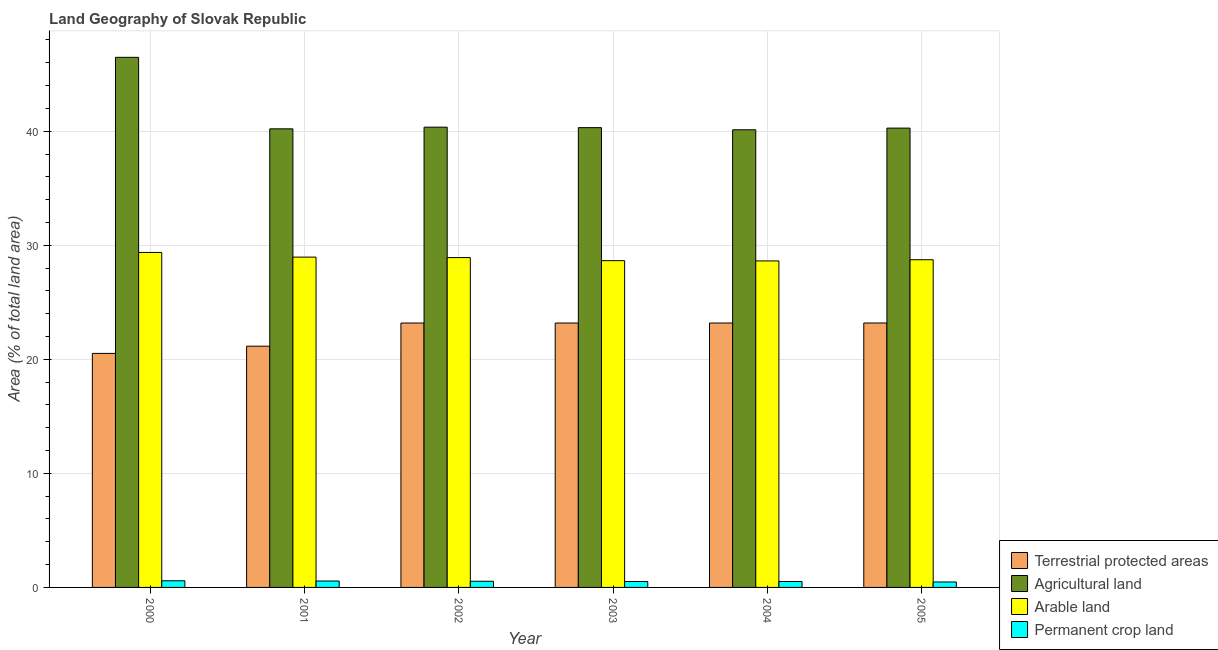How many different coloured bars are there?
Provide a succinct answer. 4. Are the number of bars per tick equal to the number of legend labels?
Make the answer very short. Yes. In how many cases, is the number of bars for a given year not equal to the number of legend labels?
Ensure brevity in your answer.  0. What is the percentage of area under permanent crop land in 2004?
Your answer should be compact. 0.52. Across all years, what is the maximum percentage of area under arable land?
Offer a terse response. 29.37. Across all years, what is the minimum percentage of area under agricultural land?
Your response must be concise. 40.12. In which year was the percentage of area under permanent crop land minimum?
Ensure brevity in your answer.  2005. What is the total percentage of area under permanent crop land in the graph?
Keep it short and to the point. 3.2. What is the difference between the percentage of area under permanent crop land in 2001 and that in 2003?
Give a very brief answer. 0.04. What is the difference between the percentage of area under arable land in 2003 and the percentage of land under terrestrial protection in 2002?
Offer a very short reply. -0.27. What is the average percentage of area under permanent crop land per year?
Provide a short and direct response. 0.53. What is the ratio of the percentage of area under agricultural land in 2000 to that in 2004?
Make the answer very short. 1.16. What is the difference between the highest and the second highest percentage of area under agricultural land?
Ensure brevity in your answer.  6.12. What is the difference between the highest and the lowest percentage of area under permanent crop land?
Your response must be concise. 0.1. Is the sum of the percentage of land under terrestrial protection in 2000 and 2005 greater than the maximum percentage of area under permanent crop land across all years?
Ensure brevity in your answer.  Yes. What does the 4th bar from the left in 2000 represents?
Your response must be concise. Permanent crop land. What does the 1st bar from the right in 2001 represents?
Keep it short and to the point. Permanent crop land. Is it the case that in every year, the sum of the percentage of land under terrestrial protection and percentage of area under agricultural land is greater than the percentage of area under arable land?
Keep it short and to the point. Yes. How many bars are there?
Offer a terse response. 24. Are the values on the major ticks of Y-axis written in scientific E-notation?
Make the answer very short. No. Does the graph contain any zero values?
Offer a very short reply. No. Where does the legend appear in the graph?
Provide a short and direct response. Bottom right. How many legend labels are there?
Provide a short and direct response. 4. What is the title of the graph?
Ensure brevity in your answer.  Land Geography of Slovak Republic. What is the label or title of the Y-axis?
Provide a short and direct response. Area (% of total land area). What is the Area (% of total land area) of Terrestrial protected areas in 2000?
Give a very brief answer. 20.52. What is the Area (% of total land area) of Agricultural land in 2000?
Give a very brief answer. 46.48. What is the Area (% of total land area) in Arable land in 2000?
Keep it short and to the point. 29.37. What is the Area (% of total land area) of Permanent crop land in 2000?
Provide a short and direct response. 0.58. What is the Area (% of total land area) of Terrestrial protected areas in 2001?
Your response must be concise. 21.15. What is the Area (% of total land area) of Agricultural land in 2001?
Your answer should be compact. 40.21. What is the Area (% of total land area) in Arable land in 2001?
Offer a very short reply. 28.96. What is the Area (% of total land area) in Permanent crop land in 2001?
Keep it short and to the point. 0.56. What is the Area (% of total land area) of Terrestrial protected areas in 2002?
Provide a short and direct response. 23.18. What is the Area (% of total land area) of Agricultural land in 2002?
Keep it short and to the point. 40.35. What is the Area (% of total land area) in Arable land in 2002?
Provide a short and direct response. 28.92. What is the Area (% of total land area) of Permanent crop land in 2002?
Your response must be concise. 0.54. What is the Area (% of total land area) of Terrestrial protected areas in 2003?
Provide a short and direct response. 23.18. What is the Area (% of total land area) of Agricultural land in 2003?
Give a very brief answer. 40.31. What is the Area (% of total land area) in Arable land in 2003?
Ensure brevity in your answer.  28.65. What is the Area (% of total land area) in Permanent crop land in 2003?
Make the answer very short. 0.52. What is the Area (% of total land area) in Terrestrial protected areas in 2004?
Offer a very short reply. 23.18. What is the Area (% of total land area) in Agricultural land in 2004?
Your response must be concise. 40.12. What is the Area (% of total land area) in Arable land in 2004?
Your answer should be very brief. 28.63. What is the Area (% of total land area) in Permanent crop land in 2004?
Make the answer very short. 0.52. What is the Area (% of total land area) of Terrestrial protected areas in 2005?
Offer a very short reply. 23.18. What is the Area (% of total land area) of Agricultural land in 2005?
Your answer should be very brief. 40.27. What is the Area (% of total land area) in Arable land in 2005?
Your answer should be very brief. 28.73. What is the Area (% of total land area) in Permanent crop land in 2005?
Ensure brevity in your answer.  0.48. Across all years, what is the maximum Area (% of total land area) in Terrestrial protected areas?
Offer a very short reply. 23.18. Across all years, what is the maximum Area (% of total land area) of Agricultural land?
Your answer should be compact. 46.48. Across all years, what is the maximum Area (% of total land area) of Arable land?
Make the answer very short. 29.37. Across all years, what is the maximum Area (% of total land area) of Permanent crop land?
Offer a terse response. 0.58. Across all years, what is the minimum Area (% of total land area) in Terrestrial protected areas?
Keep it short and to the point. 20.52. Across all years, what is the minimum Area (% of total land area) in Agricultural land?
Provide a short and direct response. 40.12. Across all years, what is the minimum Area (% of total land area) in Arable land?
Offer a very short reply. 28.63. Across all years, what is the minimum Area (% of total land area) of Permanent crop land?
Offer a very short reply. 0.48. What is the total Area (% of total land area) in Terrestrial protected areas in the graph?
Ensure brevity in your answer.  134.4. What is the total Area (% of total land area) of Agricultural land in the graph?
Provide a succinct answer. 247.75. What is the total Area (% of total land area) in Arable land in the graph?
Your answer should be very brief. 173.26. What is the total Area (% of total land area) of Permanent crop land in the graph?
Give a very brief answer. 3.2. What is the difference between the Area (% of total land area) in Terrestrial protected areas in 2000 and that in 2001?
Your answer should be very brief. -0.63. What is the difference between the Area (% of total land area) of Agricultural land in 2000 and that in 2001?
Give a very brief answer. 6.27. What is the difference between the Area (% of total land area) of Arable land in 2000 and that in 2001?
Provide a succinct answer. 0.41. What is the difference between the Area (% of total land area) of Permanent crop land in 2000 and that in 2001?
Make the answer very short. 0.02. What is the difference between the Area (% of total land area) of Terrestrial protected areas in 2000 and that in 2002?
Offer a very short reply. -2.66. What is the difference between the Area (% of total land area) of Agricultural land in 2000 and that in 2002?
Keep it short and to the point. 6.12. What is the difference between the Area (% of total land area) in Arable land in 2000 and that in 2002?
Your answer should be very brief. 0.45. What is the difference between the Area (% of total land area) of Permanent crop land in 2000 and that in 2002?
Your response must be concise. 0.04. What is the difference between the Area (% of total land area) of Terrestrial protected areas in 2000 and that in 2003?
Offer a terse response. -2.66. What is the difference between the Area (% of total land area) in Agricultural land in 2000 and that in 2003?
Give a very brief answer. 6.17. What is the difference between the Area (% of total land area) in Arable land in 2000 and that in 2003?
Your response must be concise. 0.72. What is the difference between the Area (% of total land area) of Permanent crop land in 2000 and that in 2003?
Your answer should be very brief. 0.06. What is the difference between the Area (% of total land area) of Terrestrial protected areas in 2000 and that in 2004?
Your answer should be compact. -2.66. What is the difference between the Area (% of total land area) in Agricultural land in 2000 and that in 2004?
Give a very brief answer. 6.35. What is the difference between the Area (% of total land area) of Arable land in 2000 and that in 2004?
Make the answer very short. 0.74. What is the difference between the Area (% of total land area) in Permanent crop land in 2000 and that in 2004?
Offer a terse response. 0.06. What is the difference between the Area (% of total land area) of Terrestrial protected areas in 2000 and that in 2005?
Provide a short and direct response. -2.67. What is the difference between the Area (% of total land area) in Agricultural land in 2000 and that in 2005?
Offer a very short reply. 6.21. What is the difference between the Area (% of total land area) in Arable land in 2000 and that in 2005?
Keep it short and to the point. 0.64. What is the difference between the Area (% of total land area) of Permanent crop land in 2000 and that in 2005?
Your response must be concise. 0.1. What is the difference between the Area (% of total land area) of Terrestrial protected areas in 2001 and that in 2002?
Your answer should be compact. -2.03. What is the difference between the Area (% of total land area) of Agricultural land in 2001 and that in 2002?
Your answer should be compact. -0.15. What is the difference between the Area (% of total land area) of Arable land in 2001 and that in 2002?
Ensure brevity in your answer.  0.04. What is the difference between the Area (% of total land area) of Permanent crop land in 2001 and that in 2002?
Provide a short and direct response. 0.02. What is the difference between the Area (% of total land area) in Terrestrial protected areas in 2001 and that in 2003?
Your answer should be compact. -2.03. What is the difference between the Area (% of total land area) in Agricultural land in 2001 and that in 2003?
Keep it short and to the point. -0.1. What is the difference between the Area (% of total land area) of Arable land in 2001 and that in 2003?
Give a very brief answer. 0.31. What is the difference between the Area (% of total land area) in Permanent crop land in 2001 and that in 2003?
Offer a very short reply. 0.04. What is the difference between the Area (% of total land area) in Terrestrial protected areas in 2001 and that in 2004?
Your answer should be compact. -2.03. What is the difference between the Area (% of total land area) of Agricultural land in 2001 and that in 2004?
Your answer should be compact. 0.08. What is the difference between the Area (% of total land area) in Arable land in 2001 and that in 2004?
Give a very brief answer. 0.33. What is the difference between the Area (% of total land area) of Permanent crop land in 2001 and that in 2004?
Provide a succinct answer. 0.04. What is the difference between the Area (% of total land area) in Terrestrial protected areas in 2001 and that in 2005?
Provide a succinct answer. -2.03. What is the difference between the Area (% of total land area) of Agricultural land in 2001 and that in 2005?
Your answer should be compact. -0.06. What is the difference between the Area (% of total land area) of Arable land in 2001 and that in 2005?
Provide a succinct answer. 0.23. What is the difference between the Area (% of total land area) in Permanent crop land in 2001 and that in 2005?
Offer a very short reply. 0.08. What is the difference between the Area (% of total land area) in Terrestrial protected areas in 2002 and that in 2003?
Offer a very short reply. -0. What is the difference between the Area (% of total land area) in Agricultural land in 2002 and that in 2003?
Ensure brevity in your answer.  0.04. What is the difference between the Area (% of total land area) of Arable land in 2002 and that in 2003?
Make the answer very short. 0.27. What is the difference between the Area (% of total land area) of Permanent crop land in 2002 and that in 2003?
Keep it short and to the point. 0.02. What is the difference between the Area (% of total land area) in Terrestrial protected areas in 2002 and that in 2004?
Make the answer very short. -0. What is the difference between the Area (% of total land area) in Agricultural land in 2002 and that in 2004?
Give a very brief answer. 0.23. What is the difference between the Area (% of total land area) of Arable land in 2002 and that in 2004?
Your answer should be very brief. 0.29. What is the difference between the Area (% of total land area) in Permanent crop land in 2002 and that in 2004?
Give a very brief answer. 0.02. What is the difference between the Area (% of total land area) of Terrestrial protected areas in 2002 and that in 2005?
Provide a succinct answer. -0. What is the difference between the Area (% of total land area) in Agricultural land in 2002 and that in 2005?
Offer a very short reply. 0.08. What is the difference between the Area (% of total land area) in Arable land in 2002 and that in 2005?
Your response must be concise. 0.19. What is the difference between the Area (% of total land area) in Permanent crop land in 2002 and that in 2005?
Ensure brevity in your answer.  0.06. What is the difference between the Area (% of total land area) of Terrestrial protected areas in 2003 and that in 2004?
Your answer should be compact. -0. What is the difference between the Area (% of total land area) in Agricultural land in 2003 and that in 2004?
Make the answer very short. 0.19. What is the difference between the Area (% of total land area) of Arable land in 2003 and that in 2004?
Give a very brief answer. 0.02. What is the difference between the Area (% of total land area) of Permanent crop land in 2003 and that in 2004?
Give a very brief answer. 0. What is the difference between the Area (% of total land area) of Terrestrial protected areas in 2003 and that in 2005?
Ensure brevity in your answer.  -0. What is the difference between the Area (% of total land area) in Agricultural land in 2003 and that in 2005?
Make the answer very short. 0.04. What is the difference between the Area (% of total land area) of Arable land in 2003 and that in 2005?
Make the answer very short. -0.08. What is the difference between the Area (% of total land area) in Permanent crop land in 2003 and that in 2005?
Ensure brevity in your answer.  0.04. What is the difference between the Area (% of total land area) in Terrestrial protected areas in 2004 and that in 2005?
Keep it short and to the point. -0. What is the difference between the Area (% of total land area) in Agricultural land in 2004 and that in 2005?
Ensure brevity in your answer.  -0.15. What is the difference between the Area (% of total land area) of Arable land in 2004 and that in 2005?
Your response must be concise. -0.1. What is the difference between the Area (% of total land area) of Permanent crop land in 2004 and that in 2005?
Your answer should be compact. 0.04. What is the difference between the Area (% of total land area) of Terrestrial protected areas in 2000 and the Area (% of total land area) of Agricultural land in 2001?
Offer a terse response. -19.69. What is the difference between the Area (% of total land area) of Terrestrial protected areas in 2000 and the Area (% of total land area) of Arable land in 2001?
Give a very brief answer. -8.44. What is the difference between the Area (% of total land area) of Terrestrial protected areas in 2000 and the Area (% of total land area) of Permanent crop land in 2001?
Ensure brevity in your answer.  19.96. What is the difference between the Area (% of total land area) of Agricultural land in 2000 and the Area (% of total land area) of Arable land in 2001?
Keep it short and to the point. 17.52. What is the difference between the Area (% of total land area) of Agricultural land in 2000 and the Area (% of total land area) of Permanent crop land in 2001?
Give a very brief answer. 45.92. What is the difference between the Area (% of total land area) of Arable land in 2000 and the Area (% of total land area) of Permanent crop land in 2001?
Offer a terse response. 28.81. What is the difference between the Area (% of total land area) in Terrestrial protected areas in 2000 and the Area (% of total land area) in Agricultural land in 2002?
Ensure brevity in your answer.  -19.83. What is the difference between the Area (% of total land area) in Terrestrial protected areas in 2000 and the Area (% of total land area) in Arable land in 2002?
Keep it short and to the point. -8.4. What is the difference between the Area (% of total land area) in Terrestrial protected areas in 2000 and the Area (% of total land area) in Permanent crop land in 2002?
Your answer should be compact. 19.98. What is the difference between the Area (% of total land area) of Agricultural land in 2000 and the Area (% of total land area) of Arable land in 2002?
Your answer should be very brief. 17.56. What is the difference between the Area (% of total land area) of Agricultural land in 2000 and the Area (% of total land area) of Permanent crop land in 2002?
Provide a short and direct response. 45.94. What is the difference between the Area (% of total land area) of Arable land in 2000 and the Area (% of total land area) of Permanent crop land in 2002?
Provide a succinct answer. 28.83. What is the difference between the Area (% of total land area) in Terrestrial protected areas in 2000 and the Area (% of total land area) in Agricultural land in 2003?
Your answer should be compact. -19.79. What is the difference between the Area (% of total land area) in Terrestrial protected areas in 2000 and the Area (% of total land area) in Arable land in 2003?
Your answer should be very brief. -8.13. What is the difference between the Area (% of total land area) in Terrestrial protected areas in 2000 and the Area (% of total land area) in Permanent crop land in 2003?
Offer a terse response. 20. What is the difference between the Area (% of total land area) of Agricultural land in 2000 and the Area (% of total land area) of Arable land in 2003?
Your answer should be compact. 17.83. What is the difference between the Area (% of total land area) in Agricultural land in 2000 and the Area (% of total land area) in Permanent crop land in 2003?
Provide a short and direct response. 45.96. What is the difference between the Area (% of total land area) of Arable land in 2000 and the Area (% of total land area) of Permanent crop land in 2003?
Offer a terse response. 28.85. What is the difference between the Area (% of total land area) of Terrestrial protected areas in 2000 and the Area (% of total land area) of Agricultural land in 2004?
Give a very brief answer. -19.61. What is the difference between the Area (% of total land area) in Terrestrial protected areas in 2000 and the Area (% of total land area) in Arable land in 2004?
Give a very brief answer. -8.11. What is the difference between the Area (% of total land area) of Terrestrial protected areas in 2000 and the Area (% of total land area) of Permanent crop land in 2004?
Offer a very short reply. 20. What is the difference between the Area (% of total land area) of Agricultural land in 2000 and the Area (% of total land area) of Arable land in 2004?
Your answer should be compact. 17.85. What is the difference between the Area (% of total land area) in Agricultural land in 2000 and the Area (% of total land area) in Permanent crop land in 2004?
Provide a succinct answer. 45.96. What is the difference between the Area (% of total land area) in Arable land in 2000 and the Area (% of total land area) in Permanent crop land in 2004?
Offer a terse response. 28.85. What is the difference between the Area (% of total land area) in Terrestrial protected areas in 2000 and the Area (% of total land area) in Agricultural land in 2005?
Provide a short and direct response. -19.75. What is the difference between the Area (% of total land area) in Terrestrial protected areas in 2000 and the Area (% of total land area) in Arable land in 2005?
Your answer should be very brief. -8.21. What is the difference between the Area (% of total land area) in Terrestrial protected areas in 2000 and the Area (% of total land area) in Permanent crop land in 2005?
Provide a succinct answer. 20.04. What is the difference between the Area (% of total land area) of Agricultural land in 2000 and the Area (% of total land area) of Arable land in 2005?
Your answer should be very brief. 17.75. What is the difference between the Area (% of total land area) in Agricultural land in 2000 and the Area (% of total land area) in Permanent crop land in 2005?
Your answer should be very brief. 46. What is the difference between the Area (% of total land area) in Arable land in 2000 and the Area (% of total land area) in Permanent crop land in 2005?
Offer a very short reply. 28.89. What is the difference between the Area (% of total land area) of Terrestrial protected areas in 2001 and the Area (% of total land area) of Agricultural land in 2002?
Provide a short and direct response. -19.2. What is the difference between the Area (% of total land area) of Terrestrial protected areas in 2001 and the Area (% of total land area) of Arable land in 2002?
Make the answer very short. -7.77. What is the difference between the Area (% of total land area) in Terrestrial protected areas in 2001 and the Area (% of total land area) in Permanent crop land in 2002?
Offer a very short reply. 20.61. What is the difference between the Area (% of total land area) of Agricultural land in 2001 and the Area (% of total land area) of Arable land in 2002?
Give a very brief answer. 11.29. What is the difference between the Area (% of total land area) in Agricultural land in 2001 and the Area (% of total land area) in Permanent crop land in 2002?
Make the answer very short. 39.67. What is the difference between the Area (% of total land area) of Arable land in 2001 and the Area (% of total land area) of Permanent crop land in 2002?
Provide a succinct answer. 28.42. What is the difference between the Area (% of total land area) in Terrestrial protected areas in 2001 and the Area (% of total land area) in Agricultural land in 2003?
Make the answer very short. -19.16. What is the difference between the Area (% of total land area) of Terrestrial protected areas in 2001 and the Area (% of total land area) of Arable land in 2003?
Ensure brevity in your answer.  -7.5. What is the difference between the Area (% of total land area) in Terrestrial protected areas in 2001 and the Area (% of total land area) in Permanent crop land in 2003?
Provide a succinct answer. 20.63. What is the difference between the Area (% of total land area) of Agricultural land in 2001 and the Area (% of total land area) of Arable land in 2003?
Keep it short and to the point. 11.56. What is the difference between the Area (% of total land area) of Agricultural land in 2001 and the Area (% of total land area) of Permanent crop land in 2003?
Your response must be concise. 39.69. What is the difference between the Area (% of total land area) of Arable land in 2001 and the Area (% of total land area) of Permanent crop land in 2003?
Give a very brief answer. 28.44. What is the difference between the Area (% of total land area) in Terrestrial protected areas in 2001 and the Area (% of total land area) in Agricultural land in 2004?
Offer a terse response. -18.97. What is the difference between the Area (% of total land area) in Terrestrial protected areas in 2001 and the Area (% of total land area) in Arable land in 2004?
Offer a terse response. -7.48. What is the difference between the Area (% of total land area) of Terrestrial protected areas in 2001 and the Area (% of total land area) of Permanent crop land in 2004?
Give a very brief answer. 20.63. What is the difference between the Area (% of total land area) in Agricultural land in 2001 and the Area (% of total land area) in Arable land in 2004?
Your response must be concise. 11.58. What is the difference between the Area (% of total land area) of Agricultural land in 2001 and the Area (% of total land area) of Permanent crop land in 2004?
Provide a short and direct response. 39.69. What is the difference between the Area (% of total land area) in Arable land in 2001 and the Area (% of total land area) in Permanent crop land in 2004?
Make the answer very short. 28.44. What is the difference between the Area (% of total land area) in Terrestrial protected areas in 2001 and the Area (% of total land area) in Agricultural land in 2005?
Ensure brevity in your answer.  -19.12. What is the difference between the Area (% of total land area) in Terrestrial protected areas in 2001 and the Area (% of total land area) in Arable land in 2005?
Offer a terse response. -7.58. What is the difference between the Area (% of total land area) in Terrestrial protected areas in 2001 and the Area (% of total land area) in Permanent crop land in 2005?
Your answer should be compact. 20.67. What is the difference between the Area (% of total land area) of Agricultural land in 2001 and the Area (% of total land area) of Arable land in 2005?
Make the answer very short. 11.48. What is the difference between the Area (% of total land area) of Agricultural land in 2001 and the Area (% of total land area) of Permanent crop land in 2005?
Provide a succinct answer. 39.73. What is the difference between the Area (% of total land area) of Arable land in 2001 and the Area (% of total land area) of Permanent crop land in 2005?
Offer a very short reply. 28.48. What is the difference between the Area (% of total land area) of Terrestrial protected areas in 2002 and the Area (% of total land area) of Agricultural land in 2003?
Ensure brevity in your answer.  -17.13. What is the difference between the Area (% of total land area) of Terrestrial protected areas in 2002 and the Area (% of total land area) of Arable land in 2003?
Keep it short and to the point. -5.47. What is the difference between the Area (% of total land area) in Terrestrial protected areas in 2002 and the Area (% of total land area) in Permanent crop land in 2003?
Make the answer very short. 22.66. What is the difference between the Area (% of total land area) of Agricultural land in 2002 and the Area (% of total land area) of Arable land in 2003?
Your response must be concise. 11.7. What is the difference between the Area (% of total land area) of Agricultural land in 2002 and the Area (% of total land area) of Permanent crop land in 2003?
Make the answer very short. 39.83. What is the difference between the Area (% of total land area) of Arable land in 2002 and the Area (% of total land area) of Permanent crop land in 2003?
Give a very brief answer. 28.4. What is the difference between the Area (% of total land area) of Terrestrial protected areas in 2002 and the Area (% of total land area) of Agricultural land in 2004?
Your response must be concise. -16.94. What is the difference between the Area (% of total land area) in Terrestrial protected areas in 2002 and the Area (% of total land area) in Arable land in 2004?
Your response must be concise. -5.45. What is the difference between the Area (% of total land area) of Terrestrial protected areas in 2002 and the Area (% of total land area) of Permanent crop land in 2004?
Offer a very short reply. 22.66. What is the difference between the Area (% of total land area) in Agricultural land in 2002 and the Area (% of total land area) in Arable land in 2004?
Provide a short and direct response. 11.73. What is the difference between the Area (% of total land area) in Agricultural land in 2002 and the Area (% of total land area) in Permanent crop land in 2004?
Give a very brief answer. 39.83. What is the difference between the Area (% of total land area) in Arable land in 2002 and the Area (% of total land area) in Permanent crop land in 2004?
Keep it short and to the point. 28.4. What is the difference between the Area (% of total land area) in Terrestrial protected areas in 2002 and the Area (% of total land area) in Agricultural land in 2005?
Your answer should be compact. -17.09. What is the difference between the Area (% of total land area) of Terrestrial protected areas in 2002 and the Area (% of total land area) of Arable land in 2005?
Ensure brevity in your answer.  -5.55. What is the difference between the Area (% of total land area) in Terrestrial protected areas in 2002 and the Area (% of total land area) in Permanent crop land in 2005?
Your response must be concise. 22.7. What is the difference between the Area (% of total land area) of Agricultural land in 2002 and the Area (% of total land area) of Arable land in 2005?
Offer a terse response. 11.62. What is the difference between the Area (% of total land area) of Agricultural land in 2002 and the Area (% of total land area) of Permanent crop land in 2005?
Your answer should be compact. 39.88. What is the difference between the Area (% of total land area) in Arable land in 2002 and the Area (% of total land area) in Permanent crop land in 2005?
Provide a succinct answer. 28.44. What is the difference between the Area (% of total land area) of Terrestrial protected areas in 2003 and the Area (% of total land area) of Agricultural land in 2004?
Provide a short and direct response. -16.94. What is the difference between the Area (% of total land area) in Terrestrial protected areas in 2003 and the Area (% of total land area) in Arable land in 2004?
Your answer should be compact. -5.45. What is the difference between the Area (% of total land area) in Terrestrial protected areas in 2003 and the Area (% of total land area) in Permanent crop land in 2004?
Provide a succinct answer. 22.66. What is the difference between the Area (% of total land area) of Agricultural land in 2003 and the Area (% of total land area) of Arable land in 2004?
Give a very brief answer. 11.68. What is the difference between the Area (% of total land area) of Agricultural land in 2003 and the Area (% of total land area) of Permanent crop land in 2004?
Ensure brevity in your answer.  39.79. What is the difference between the Area (% of total land area) in Arable land in 2003 and the Area (% of total land area) in Permanent crop land in 2004?
Your response must be concise. 28.13. What is the difference between the Area (% of total land area) of Terrestrial protected areas in 2003 and the Area (% of total land area) of Agricultural land in 2005?
Ensure brevity in your answer.  -17.09. What is the difference between the Area (% of total land area) in Terrestrial protected areas in 2003 and the Area (% of total land area) in Arable land in 2005?
Your answer should be very brief. -5.55. What is the difference between the Area (% of total land area) in Terrestrial protected areas in 2003 and the Area (% of total land area) in Permanent crop land in 2005?
Provide a short and direct response. 22.7. What is the difference between the Area (% of total land area) of Agricultural land in 2003 and the Area (% of total land area) of Arable land in 2005?
Your answer should be very brief. 11.58. What is the difference between the Area (% of total land area) in Agricultural land in 2003 and the Area (% of total land area) in Permanent crop land in 2005?
Provide a succinct answer. 39.83. What is the difference between the Area (% of total land area) of Arable land in 2003 and the Area (% of total land area) of Permanent crop land in 2005?
Your answer should be compact. 28.17. What is the difference between the Area (% of total land area) in Terrestrial protected areas in 2004 and the Area (% of total land area) in Agricultural land in 2005?
Make the answer very short. -17.09. What is the difference between the Area (% of total land area) of Terrestrial protected areas in 2004 and the Area (% of total land area) of Arable land in 2005?
Make the answer very short. -5.55. What is the difference between the Area (% of total land area) in Terrestrial protected areas in 2004 and the Area (% of total land area) in Permanent crop land in 2005?
Ensure brevity in your answer.  22.7. What is the difference between the Area (% of total land area) in Agricultural land in 2004 and the Area (% of total land area) in Arable land in 2005?
Provide a short and direct response. 11.39. What is the difference between the Area (% of total land area) of Agricultural land in 2004 and the Area (% of total land area) of Permanent crop land in 2005?
Make the answer very short. 39.65. What is the difference between the Area (% of total land area) in Arable land in 2004 and the Area (% of total land area) in Permanent crop land in 2005?
Make the answer very short. 28.15. What is the average Area (% of total land area) of Terrestrial protected areas per year?
Offer a very short reply. 22.4. What is the average Area (% of total land area) of Agricultural land per year?
Your answer should be very brief. 41.29. What is the average Area (% of total land area) of Arable land per year?
Provide a short and direct response. 28.88. What is the average Area (% of total land area) in Permanent crop land per year?
Make the answer very short. 0.53. In the year 2000, what is the difference between the Area (% of total land area) of Terrestrial protected areas and Area (% of total land area) of Agricultural land?
Your response must be concise. -25.96. In the year 2000, what is the difference between the Area (% of total land area) in Terrestrial protected areas and Area (% of total land area) in Arable land?
Make the answer very short. -8.85. In the year 2000, what is the difference between the Area (% of total land area) in Terrestrial protected areas and Area (% of total land area) in Permanent crop land?
Your answer should be very brief. 19.94. In the year 2000, what is the difference between the Area (% of total land area) of Agricultural land and Area (% of total land area) of Arable land?
Provide a short and direct response. 17.11. In the year 2000, what is the difference between the Area (% of total land area) of Agricultural land and Area (% of total land area) of Permanent crop land?
Your answer should be very brief. 45.89. In the year 2000, what is the difference between the Area (% of total land area) of Arable land and Area (% of total land area) of Permanent crop land?
Make the answer very short. 28.79. In the year 2001, what is the difference between the Area (% of total land area) in Terrestrial protected areas and Area (% of total land area) in Agricultural land?
Your response must be concise. -19.06. In the year 2001, what is the difference between the Area (% of total land area) of Terrestrial protected areas and Area (% of total land area) of Arable land?
Offer a very short reply. -7.81. In the year 2001, what is the difference between the Area (% of total land area) of Terrestrial protected areas and Area (% of total land area) of Permanent crop land?
Provide a short and direct response. 20.59. In the year 2001, what is the difference between the Area (% of total land area) in Agricultural land and Area (% of total land area) in Arable land?
Give a very brief answer. 11.25. In the year 2001, what is the difference between the Area (% of total land area) of Agricultural land and Area (% of total land area) of Permanent crop land?
Provide a short and direct response. 39.65. In the year 2001, what is the difference between the Area (% of total land area) in Arable land and Area (% of total land area) in Permanent crop land?
Make the answer very short. 28.4. In the year 2002, what is the difference between the Area (% of total land area) in Terrestrial protected areas and Area (% of total land area) in Agricultural land?
Offer a very short reply. -17.17. In the year 2002, what is the difference between the Area (% of total land area) of Terrestrial protected areas and Area (% of total land area) of Arable land?
Provide a short and direct response. -5.74. In the year 2002, what is the difference between the Area (% of total land area) of Terrestrial protected areas and Area (% of total land area) of Permanent crop land?
Offer a terse response. 22.64. In the year 2002, what is the difference between the Area (% of total land area) in Agricultural land and Area (% of total land area) in Arable land?
Offer a very short reply. 11.43. In the year 2002, what is the difference between the Area (% of total land area) of Agricultural land and Area (% of total land area) of Permanent crop land?
Give a very brief answer. 39.81. In the year 2002, what is the difference between the Area (% of total land area) in Arable land and Area (% of total land area) in Permanent crop land?
Offer a terse response. 28.38. In the year 2003, what is the difference between the Area (% of total land area) of Terrestrial protected areas and Area (% of total land area) of Agricultural land?
Provide a succinct answer. -17.13. In the year 2003, what is the difference between the Area (% of total land area) of Terrestrial protected areas and Area (% of total land area) of Arable land?
Your answer should be compact. -5.47. In the year 2003, what is the difference between the Area (% of total land area) of Terrestrial protected areas and Area (% of total land area) of Permanent crop land?
Make the answer very short. 22.66. In the year 2003, what is the difference between the Area (% of total land area) in Agricultural land and Area (% of total land area) in Arable land?
Provide a succinct answer. 11.66. In the year 2003, what is the difference between the Area (% of total land area) in Agricultural land and Area (% of total land area) in Permanent crop land?
Your answer should be compact. 39.79. In the year 2003, what is the difference between the Area (% of total land area) of Arable land and Area (% of total land area) of Permanent crop land?
Provide a short and direct response. 28.13. In the year 2004, what is the difference between the Area (% of total land area) of Terrestrial protected areas and Area (% of total land area) of Agricultural land?
Your response must be concise. -16.94. In the year 2004, what is the difference between the Area (% of total land area) in Terrestrial protected areas and Area (% of total land area) in Arable land?
Your answer should be very brief. -5.44. In the year 2004, what is the difference between the Area (% of total land area) in Terrestrial protected areas and Area (% of total land area) in Permanent crop land?
Provide a succinct answer. 22.66. In the year 2004, what is the difference between the Area (% of total land area) of Agricultural land and Area (% of total land area) of Arable land?
Offer a terse response. 11.5. In the year 2004, what is the difference between the Area (% of total land area) in Agricultural land and Area (% of total land area) in Permanent crop land?
Offer a terse response. 39.6. In the year 2004, what is the difference between the Area (% of total land area) of Arable land and Area (% of total land area) of Permanent crop land?
Provide a succinct answer. 28.11. In the year 2005, what is the difference between the Area (% of total land area) of Terrestrial protected areas and Area (% of total land area) of Agricultural land?
Ensure brevity in your answer.  -17.09. In the year 2005, what is the difference between the Area (% of total land area) in Terrestrial protected areas and Area (% of total land area) in Arable land?
Provide a short and direct response. -5.55. In the year 2005, what is the difference between the Area (% of total land area) of Terrestrial protected areas and Area (% of total land area) of Permanent crop land?
Give a very brief answer. 22.71. In the year 2005, what is the difference between the Area (% of total land area) of Agricultural land and Area (% of total land area) of Arable land?
Provide a succinct answer. 11.54. In the year 2005, what is the difference between the Area (% of total land area) in Agricultural land and Area (% of total land area) in Permanent crop land?
Offer a terse response. 39.79. In the year 2005, what is the difference between the Area (% of total land area) of Arable land and Area (% of total land area) of Permanent crop land?
Your answer should be compact. 28.25. What is the ratio of the Area (% of total land area) in Terrestrial protected areas in 2000 to that in 2001?
Keep it short and to the point. 0.97. What is the ratio of the Area (% of total land area) of Agricultural land in 2000 to that in 2001?
Offer a very short reply. 1.16. What is the ratio of the Area (% of total land area) in Arable land in 2000 to that in 2001?
Your answer should be compact. 1.01. What is the ratio of the Area (% of total land area) of Permanent crop land in 2000 to that in 2001?
Make the answer very short. 1.04. What is the ratio of the Area (% of total land area) in Terrestrial protected areas in 2000 to that in 2002?
Your answer should be very brief. 0.89. What is the ratio of the Area (% of total land area) in Agricultural land in 2000 to that in 2002?
Your response must be concise. 1.15. What is the ratio of the Area (% of total land area) in Arable land in 2000 to that in 2002?
Your response must be concise. 1.02. What is the ratio of the Area (% of total land area) of Permanent crop land in 2000 to that in 2002?
Keep it short and to the point. 1.08. What is the ratio of the Area (% of total land area) of Terrestrial protected areas in 2000 to that in 2003?
Your answer should be very brief. 0.89. What is the ratio of the Area (% of total land area) of Agricultural land in 2000 to that in 2003?
Offer a terse response. 1.15. What is the ratio of the Area (% of total land area) of Arable land in 2000 to that in 2003?
Keep it short and to the point. 1.03. What is the ratio of the Area (% of total land area) of Permanent crop land in 2000 to that in 2003?
Keep it short and to the point. 1.12. What is the ratio of the Area (% of total land area) in Terrestrial protected areas in 2000 to that in 2004?
Provide a short and direct response. 0.89. What is the ratio of the Area (% of total land area) in Agricultural land in 2000 to that in 2004?
Provide a succinct answer. 1.16. What is the ratio of the Area (% of total land area) of Arable land in 2000 to that in 2004?
Make the answer very short. 1.03. What is the ratio of the Area (% of total land area) in Permanent crop land in 2000 to that in 2004?
Make the answer very short. 1.12. What is the ratio of the Area (% of total land area) of Terrestrial protected areas in 2000 to that in 2005?
Keep it short and to the point. 0.89. What is the ratio of the Area (% of total land area) of Agricultural land in 2000 to that in 2005?
Your response must be concise. 1.15. What is the ratio of the Area (% of total land area) of Arable land in 2000 to that in 2005?
Give a very brief answer. 1.02. What is the ratio of the Area (% of total land area) in Permanent crop land in 2000 to that in 2005?
Your answer should be very brief. 1.22. What is the ratio of the Area (% of total land area) of Terrestrial protected areas in 2001 to that in 2002?
Your response must be concise. 0.91. What is the ratio of the Area (% of total land area) in Agricultural land in 2001 to that in 2002?
Your response must be concise. 1. What is the ratio of the Area (% of total land area) of Arable land in 2001 to that in 2002?
Provide a short and direct response. 1. What is the ratio of the Area (% of total land area) in Permanent crop land in 2001 to that in 2002?
Ensure brevity in your answer.  1.04. What is the ratio of the Area (% of total land area) of Terrestrial protected areas in 2001 to that in 2003?
Ensure brevity in your answer.  0.91. What is the ratio of the Area (% of total land area) in Arable land in 2001 to that in 2003?
Offer a very short reply. 1.01. What is the ratio of the Area (% of total land area) of Terrestrial protected areas in 2001 to that in 2004?
Your answer should be very brief. 0.91. What is the ratio of the Area (% of total land area) in Arable land in 2001 to that in 2004?
Your response must be concise. 1.01. What is the ratio of the Area (% of total land area) in Terrestrial protected areas in 2001 to that in 2005?
Your answer should be very brief. 0.91. What is the ratio of the Area (% of total land area) in Agricultural land in 2001 to that in 2005?
Your response must be concise. 1. What is the ratio of the Area (% of total land area) of Permanent crop land in 2001 to that in 2005?
Provide a succinct answer. 1.17. What is the ratio of the Area (% of total land area) of Terrestrial protected areas in 2002 to that in 2003?
Your answer should be very brief. 1. What is the ratio of the Area (% of total land area) of Agricultural land in 2002 to that in 2003?
Make the answer very short. 1. What is the ratio of the Area (% of total land area) of Arable land in 2002 to that in 2003?
Your answer should be very brief. 1.01. What is the ratio of the Area (% of total land area) in Permanent crop land in 2002 to that in 2003?
Provide a short and direct response. 1.04. What is the ratio of the Area (% of total land area) of Terrestrial protected areas in 2002 to that in 2004?
Provide a succinct answer. 1. What is the ratio of the Area (% of total land area) in Arable land in 2002 to that in 2004?
Keep it short and to the point. 1.01. What is the ratio of the Area (% of total land area) in Permanent crop land in 2002 to that in 2004?
Give a very brief answer. 1.04. What is the ratio of the Area (% of total land area) of Agricultural land in 2002 to that in 2005?
Ensure brevity in your answer.  1. What is the ratio of the Area (% of total land area) of Permanent crop land in 2002 to that in 2005?
Keep it short and to the point. 1.13. What is the ratio of the Area (% of total land area) in Terrestrial protected areas in 2003 to that in 2004?
Provide a short and direct response. 1. What is the ratio of the Area (% of total land area) in Arable land in 2003 to that in 2004?
Provide a short and direct response. 1. What is the ratio of the Area (% of total land area) of Terrestrial protected areas in 2003 to that in 2005?
Your answer should be compact. 1. What is the ratio of the Area (% of total land area) in Permanent crop land in 2003 to that in 2005?
Ensure brevity in your answer.  1.09. What is the ratio of the Area (% of total land area) of Permanent crop land in 2004 to that in 2005?
Your answer should be very brief. 1.09. What is the difference between the highest and the second highest Area (% of total land area) in Terrestrial protected areas?
Give a very brief answer. 0. What is the difference between the highest and the second highest Area (% of total land area) of Agricultural land?
Provide a short and direct response. 6.12. What is the difference between the highest and the second highest Area (% of total land area) of Arable land?
Your answer should be compact. 0.41. What is the difference between the highest and the second highest Area (% of total land area) in Permanent crop land?
Offer a very short reply. 0.02. What is the difference between the highest and the lowest Area (% of total land area) in Terrestrial protected areas?
Provide a succinct answer. 2.67. What is the difference between the highest and the lowest Area (% of total land area) in Agricultural land?
Your response must be concise. 6.35. What is the difference between the highest and the lowest Area (% of total land area) of Arable land?
Your answer should be compact. 0.74. What is the difference between the highest and the lowest Area (% of total land area) in Permanent crop land?
Keep it short and to the point. 0.1. 